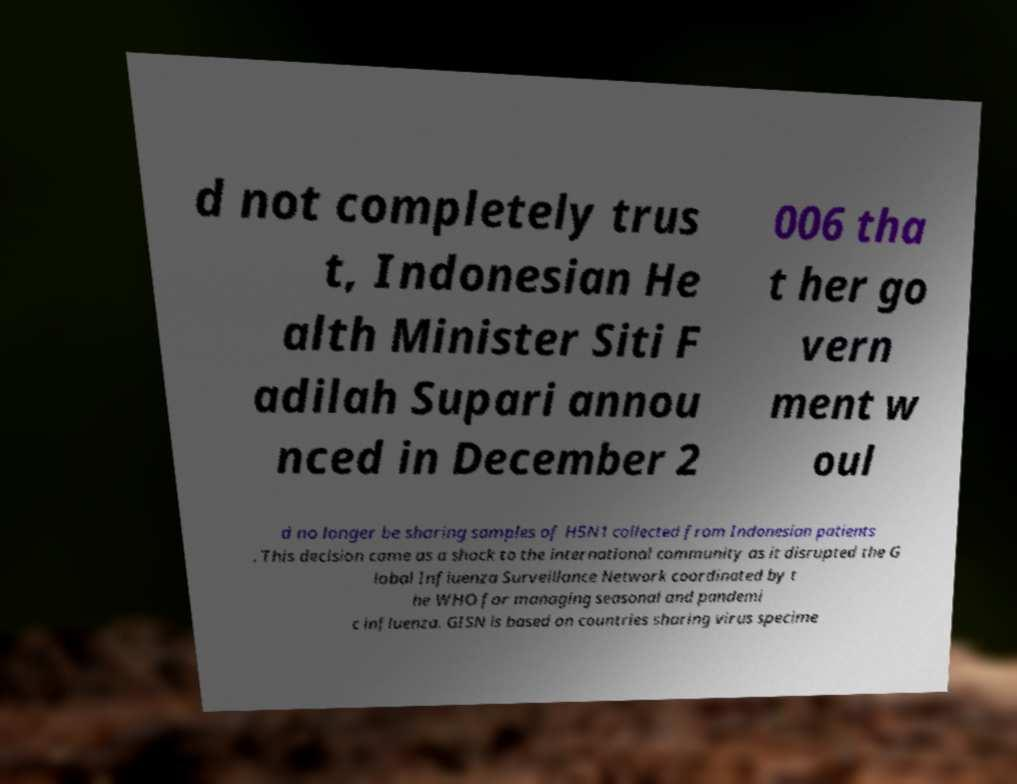Can you accurately transcribe the text from the provided image for me? d not completely trus t, Indonesian He alth Minister Siti F adilah Supari annou nced in December 2 006 tha t her go vern ment w oul d no longer be sharing samples of H5N1 collected from Indonesian patients . This decision came as a shock to the international community as it disrupted the G lobal Influenza Surveillance Network coordinated by t he WHO for managing seasonal and pandemi c influenza. GISN is based on countries sharing virus specime 